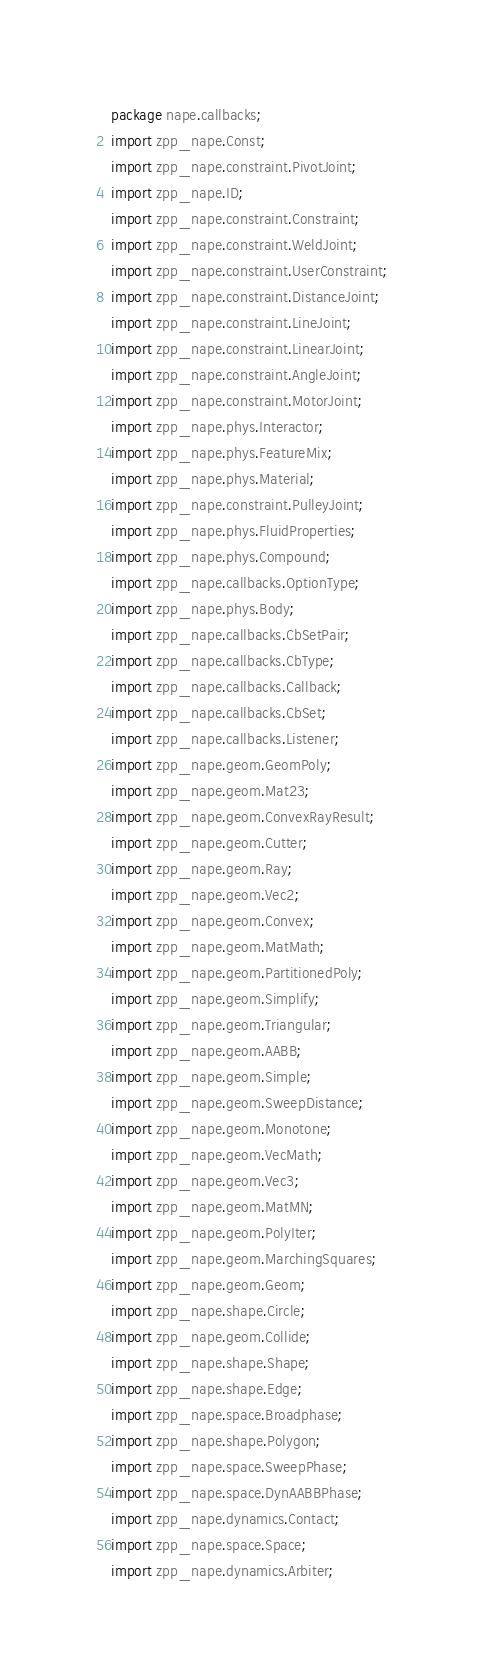<code> <loc_0><loc_0><loc_500><loc_500><_Haxe_>package nape.callbacks;
import zpp_nape.Const;
import zpp_nape.constraint.PivotJoint;
import zpp_nape.ID;
import zpp_nape.constraint.Constraint;
import zpp_nape.constraint.WeldJoint;
import zpp_nape.constraint.UserConstraint;
import zpp_nape.constraint.DistanceJoint;
import zpp_nape.constraint.LineJoint;
import zpp_nape.constraint.LinearJoint;
import zpp_nape.constraint.AngleJoint;
import zpp_nape.constraint.MotorJoint;
import zpp_nape.phys.Interactor;
import zpp_nape.phys.FeatureMix;
import zpp_nape.phys.Material;
import zpp_nape.constraint.PulleyJoint;
import zpp_nape.phys.FluidProperties;
import zpp_nape.phys.Compound;
import zpp_nape.callbacks.OptionType;
import zpp_nape.phys.Body;
import zpp_nape.callbacks.CbSetPair;
import zpp_nape.callbacks.CbType;
import zpp_nape.callbacks.Callback;
import zpp_nape.callbacks.CbSet;
import zpp_nape.callbacks.Listener;
import zpp_nape.geom.GeomPoly;
import zpp_nape.geom.Mat23;
import zpp_nape.geom.ConvexRayResult;
import zpp_nape.geom.Cutter;
import zpp_nape.geom.Ray;
import zpp_nape.geom.Vec2;
import zpp_nape.geom.Convex;
import zpp_nape.geom.MatMath;
import zpp_nape.geom.PartitionedPoly;
import zpp_nape.geom.Simplify;
import zpp_nape.geom.Triangular;
import zpp_nape.geom.AABB;
import zpp_nape.geom.Simple;
import zpp_nape.geom.SweepDistance;
import zpp_nape.geom.Monotone;
import zpp_nape.geom.VecMath;
import zpp_nape.geom.Vec3;
import zpp_nape.geom.MatMN;
import zpp_nape.geom.PolyIter;
import zpp_nape.geom.MarchingSquares;
import zpp_nape.geom.Geom;
import zpp_nape.shape.Circle;
import zpp_nape.geom.Collide;
import zpp_nape.shape.Shape;
import zpp_nape.shape.Edge;
import zpp_nape.space.Broadphase;
import zpp_nape.shape.Polygon;
import zpp_nape.space.SweepPhase;
import zpp_nape.space.DynAABBPhase;
import zpp_nape.dynamics.Contact;
import zpp_nape.space.Space;
import zpp_nape.dynamics.Arbiter;</code> 